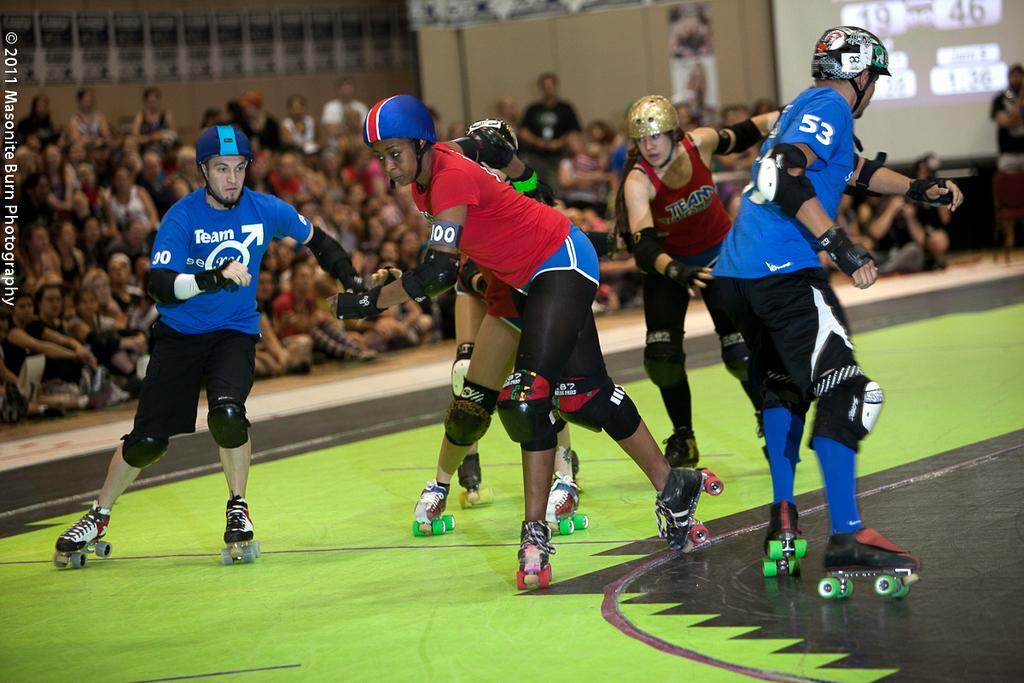How would you summarize this image in a sentence or two? In this image we can see some men and women wearing red and blue color t-shirt are doing skating. Behind there is a group of audience sitting and watching them. In the background we can see a projector screen and brown color wall. 